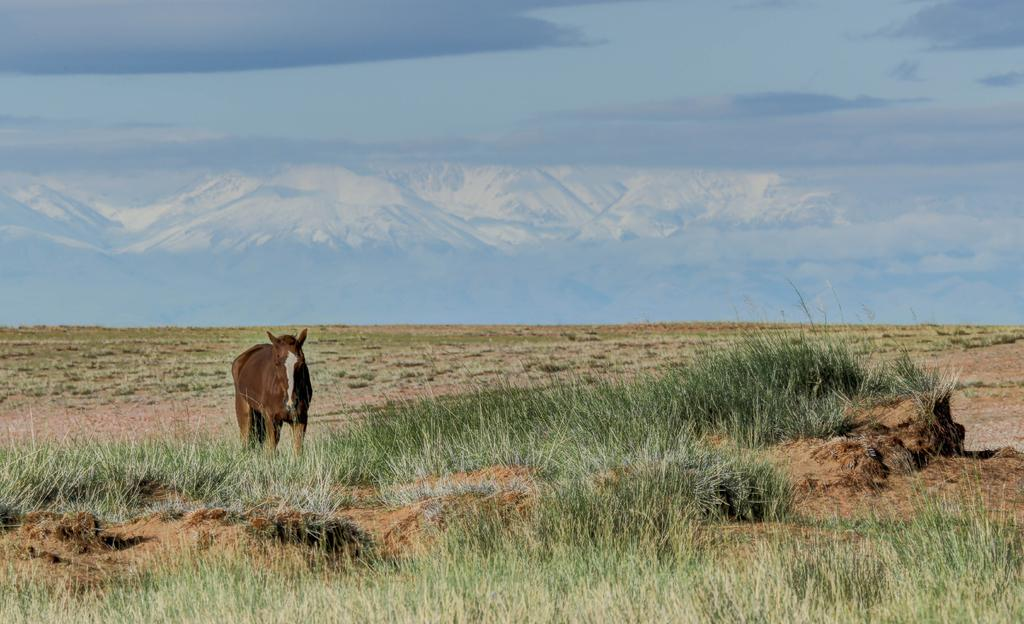What animal is present in the image? There is a horse in the image. What type of terrain is visible in the image? There is grass on the ground in the image. What can be seen in the distance in the image? There are mountains in the background of the image. What is visible above the mountains in the image? The sky is visible in the background of the image. How many clocks are hanging on the horse in the image? There are no clocks present in the image, as it features a horse in a grassy area with mountains and sky in the background. 